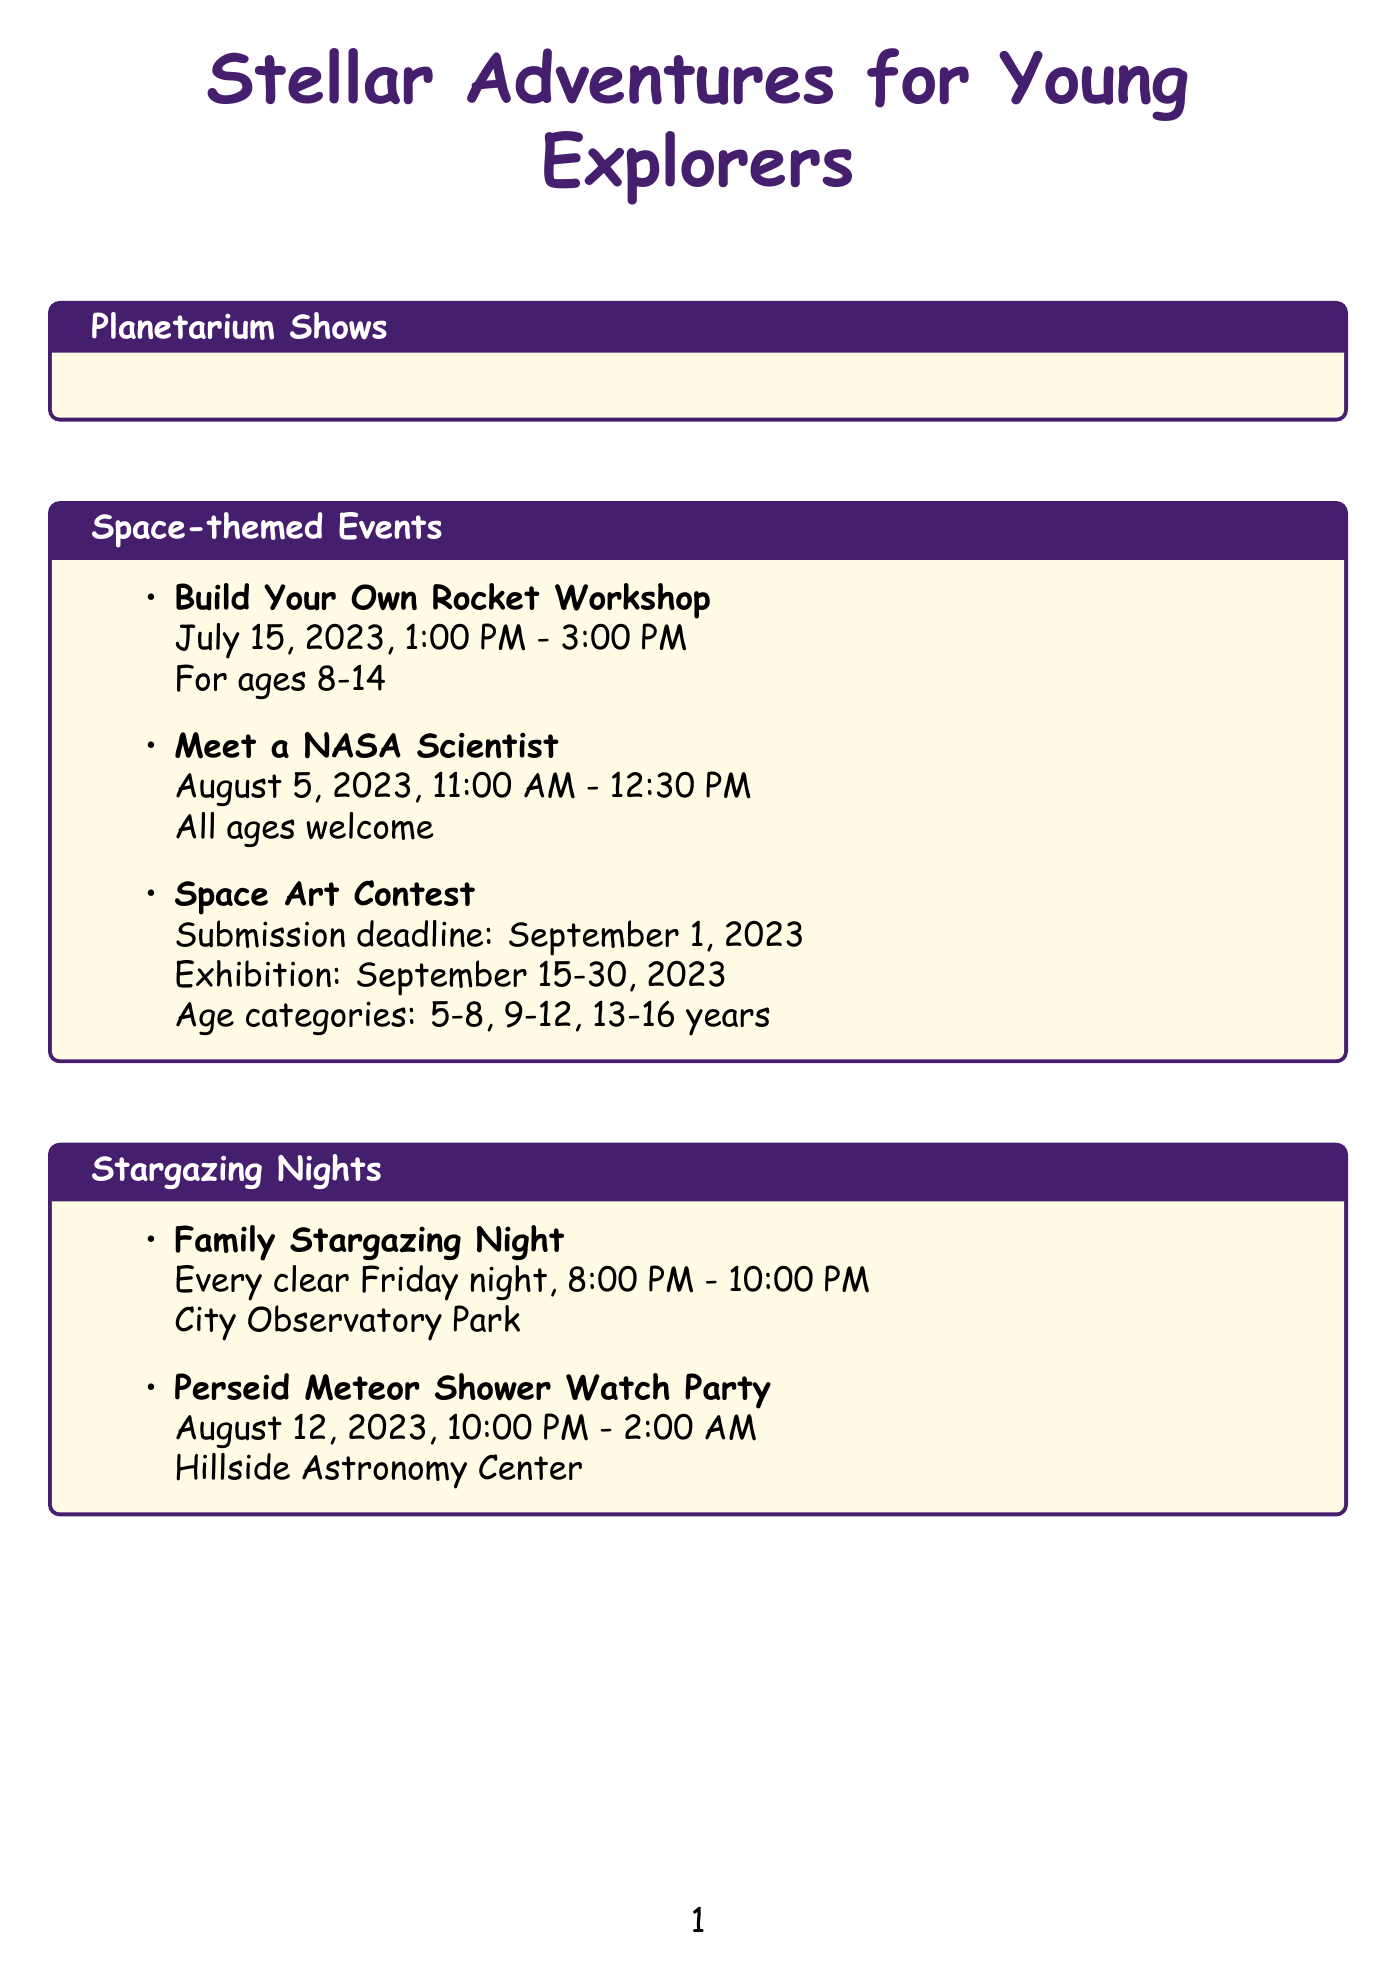What is the name of the show for ages 4-8? The document lists "Stars for Little Stargazers" as the show for ages 4-8.
Answer: Stars for Little Stargazers When does "Journey to the Moon" take place? The show "Journey to the Moon" is scheduled for Sundays at 2:00 PM.
Answer: Sundays at 2:00 PM How long is "Our Solar System Adventure"? The duration of the show "Our Solar System Adventure" is mentioned as 75 minutes.
Answer: 75 minutes What is the date of the "Build Your Own Rocket Workshop"? The document specifies that the workshop is on July 15, 2023.
Answer: July 15, 2023 Which event invites all ages? The "Meet a NASA Scientist" event welcomes attendees of all ages.
Answer: Meet a NASA Scientist On what day are stargazing nights held? The document states that Family Stargazing Night takes place every clear Friday night.
Answer: Every clear Friday night What ages can participate in the Junior Astronaut Summer Camp? The age range for the Junior Astronaut Summer Camp is stated as 8-12 years.
Answer: 8-12 years How long does "Space Art Contest" exhibition last? The exhibition for the Space Art Contest lasts from September 15 to September 30, 2023.
Answer: September 15-30, 2023 